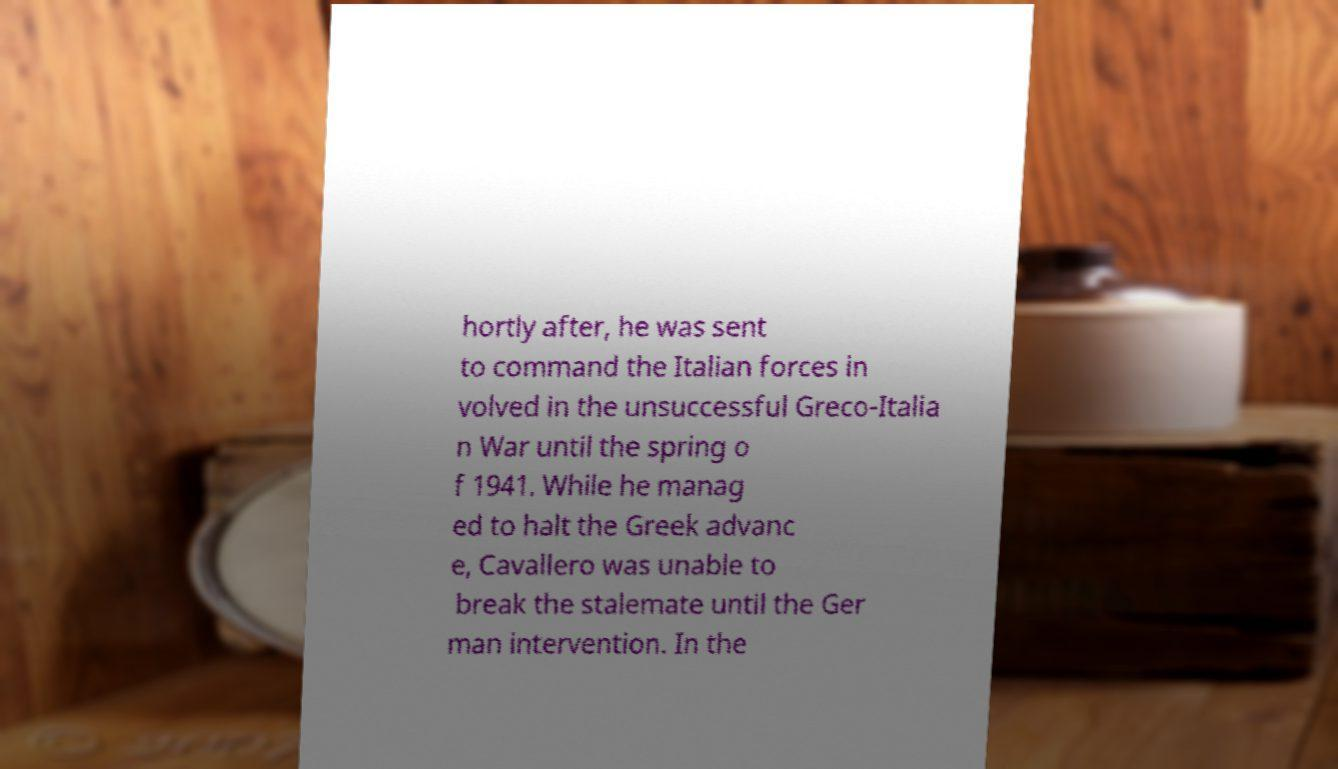Could you extract and type out the text from this image? hortly after, he was sent to command the Italian forces in volved in the unsuccessful Greco-Italia n War until the spring o f 1941. While he manag ed to halt the Greek advanc e, Cavallero was unable to break the stalemate until the Ger man intervention. In the 